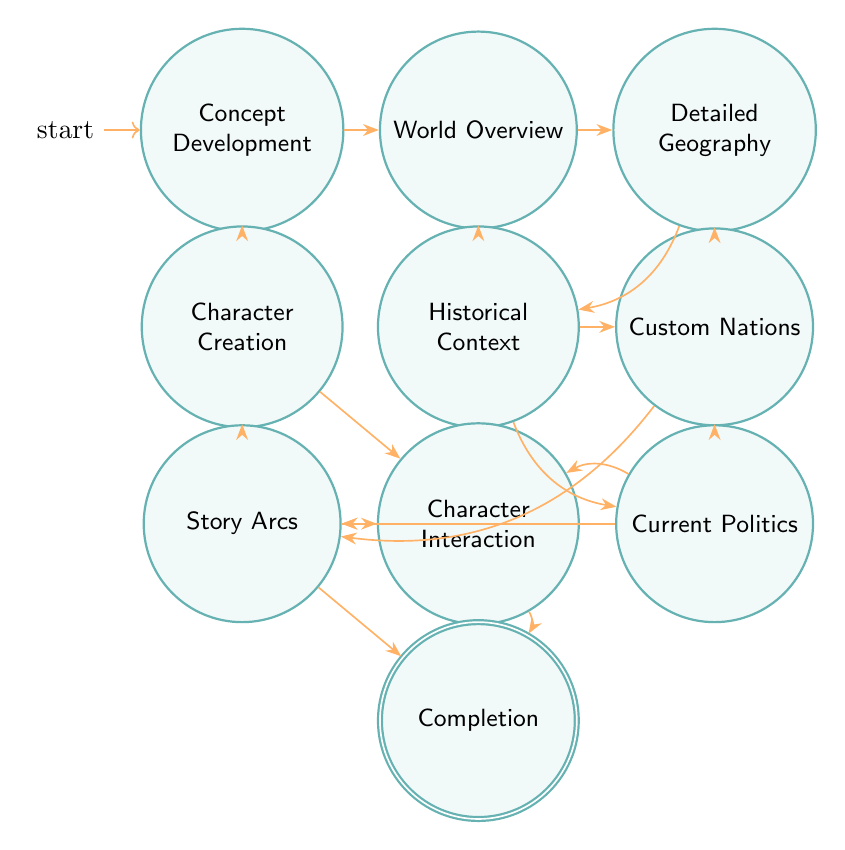What is the initial state of the diagram? The initial state is identified by the word "initial" next to the "Concept Development" node, indicating it is the starting point of the process.
Answer: Concept Development How many total states are there in the diagram? By counting the distinct nodes in the diagram, there are 10 states represented, each corresponding to different aspects of fictional world-building.
Answer: 10 Which state transitions from "World Overview"? The "World Overview" state has two arrows leading to "Detailed Geography" and "Historical Context," indicating these are the next possible states in the progression.
Answer: Detailed Geography, Historical Context What is the last state before completion? The states directly transitioning to "Completion" are "Story Arcs" and "Character Interaction." Therefore, any of these two states can be considered as the last states before reaching completion.
Answer: Story Arcs, Character Interaction Which state follows "Custom Nations"? The "Custom Nations" state transitions to "Current Politics" and "Story Arcs," indicating that either of these two states can follow it in the diagram.
Answer: Current Politics, Story Arcs What describes the "Character Creation" state? The description states that "Character Creation" focuses on designing primary characters, including their backgrounds, motivations, and roles. This highlights its function in the world-building process.
Answer: Design primary characters What transitions from "Detailed Geography"? From "Detailed Geography," two possible transitions occur: one to "Custom Nations" and another to "Historical Context," meaning it can lead to either of these.
Answer: Custom Nations, Historical Context What kind of information is established in "Historical Context"? The "Historical Context" state outlines significant historical events and their impact on the present which is critical for understanding the depth of the fictional world.
Answer: Significant historical events How many transitions are possible from the "Character Interaction" state? The "Character Interaction" state connects to two other states via transitions: it leads to "Story Arcs" and "Completion," indicating two potential paths forward.
Answer: 2 Which components are part of the "Concept Development" stage? The "Concept Development" stage defines the core themes, settings, and characters in the fictional world, establishing the groundwork for all subsequent states.
Answer: Core themes, settings, characters 